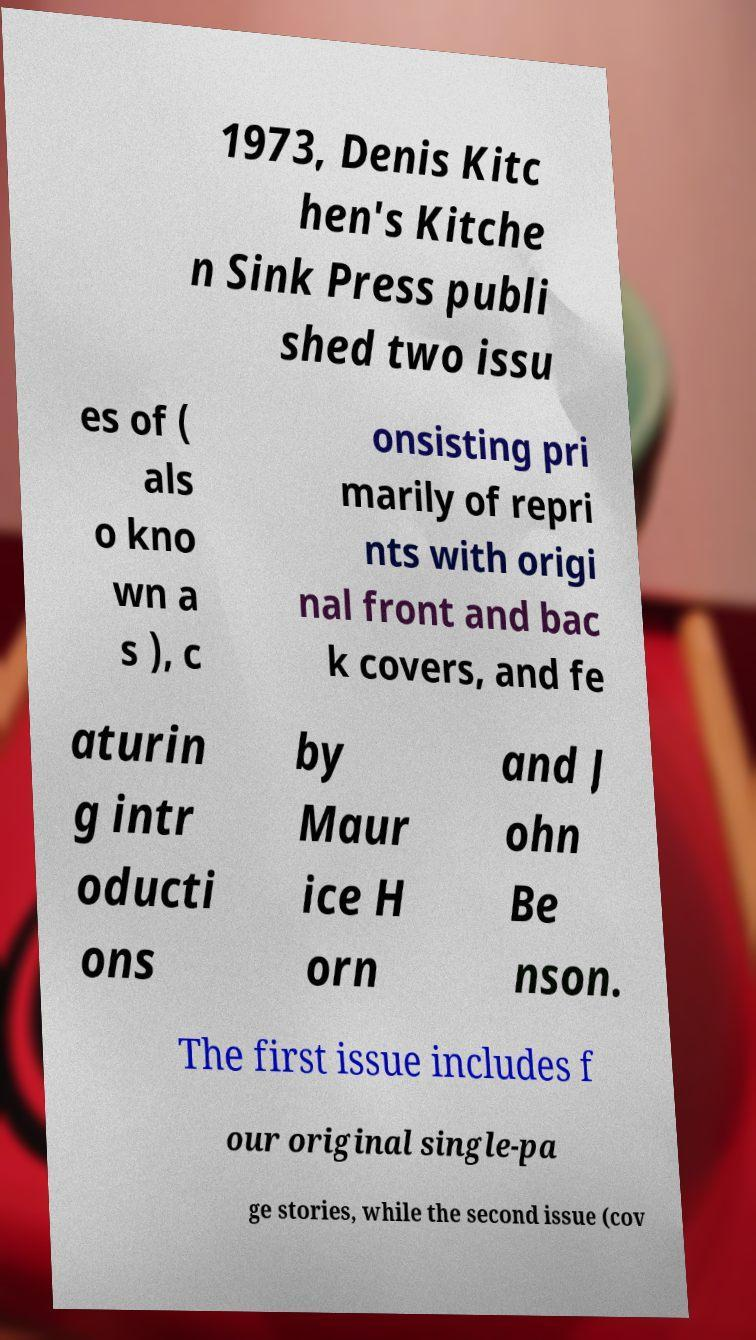Could you assist in decoding the text presented in this image and type it out clearly? 1973, Denis Kitc hen's Kitche n Sink Press publi shed two issu es of ( als o kno wn a s ), c onsisting pri marily of repri nts with origi nal front and bac k covers, and fe aturin g intr oducti ons by Maur ice H orn and J ohn Be nson. The first issue includes f our original single-pa ge stories, while the second issue (cov 